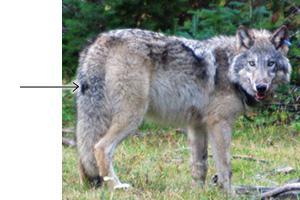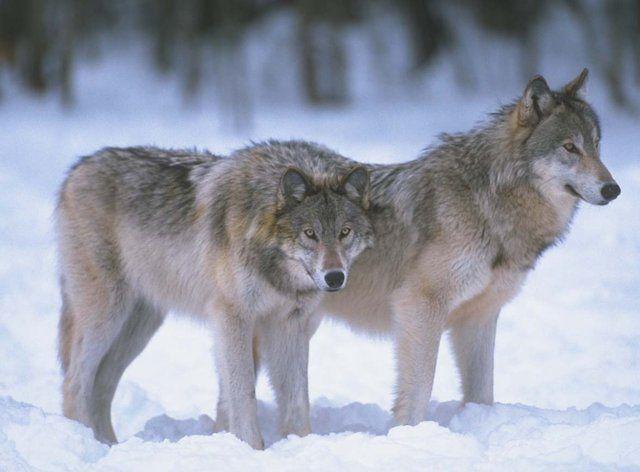The first image is the image on the left, the second image is the image on the right. Examine the images to the left and right. Is the description "There is a wolf sitting in the snow" accurate? Answer yes or no. No. 